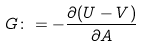<formula> <loc_0><loc_0><loc_500><loc_500>G \colon = - \frac { \partial ( U - V ) } { \partial A }</formula> 